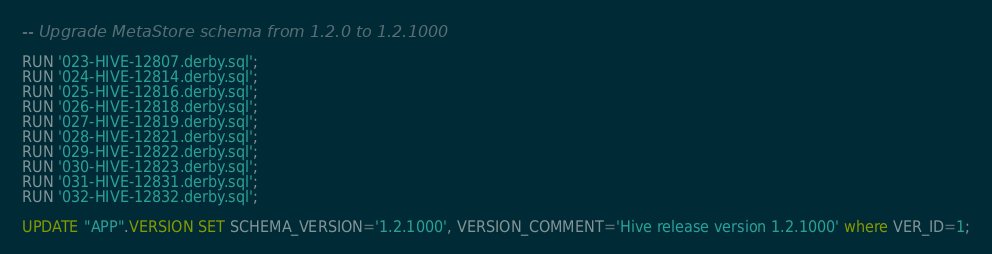<code> <loc_0><loc_0><loc_500><loc_500><_SQL_>-- Upgrade MetaStore schema from 1.2.0 to 1.2.1000

RUN '023-HIVE-12807.derby.sql';
RUN '024-HIVE-12814.derby.sql';
RUN '025-HIVE-12816.derby.sql';
RUN '026-HIVE-12818.derby.sql';
RUN '027-HIVE-12819.derby.sql';
RUN '028-HIVE-12821.derby.sql';
RUN '029-HIVE-12822.derby.sql';
RUN '030-HIVE-12823.derby.sql';
RUN '031-HIVE-12831.derby.sql';
RUN '032-HIVE-12832.derby.sql';

UPDATE "APP".VERSION SET SCHEMA_VERSION='1.2.1000', VERSION_COMMENT='Hive release version 1.2.1000' where VER_ID=1;
</code> 